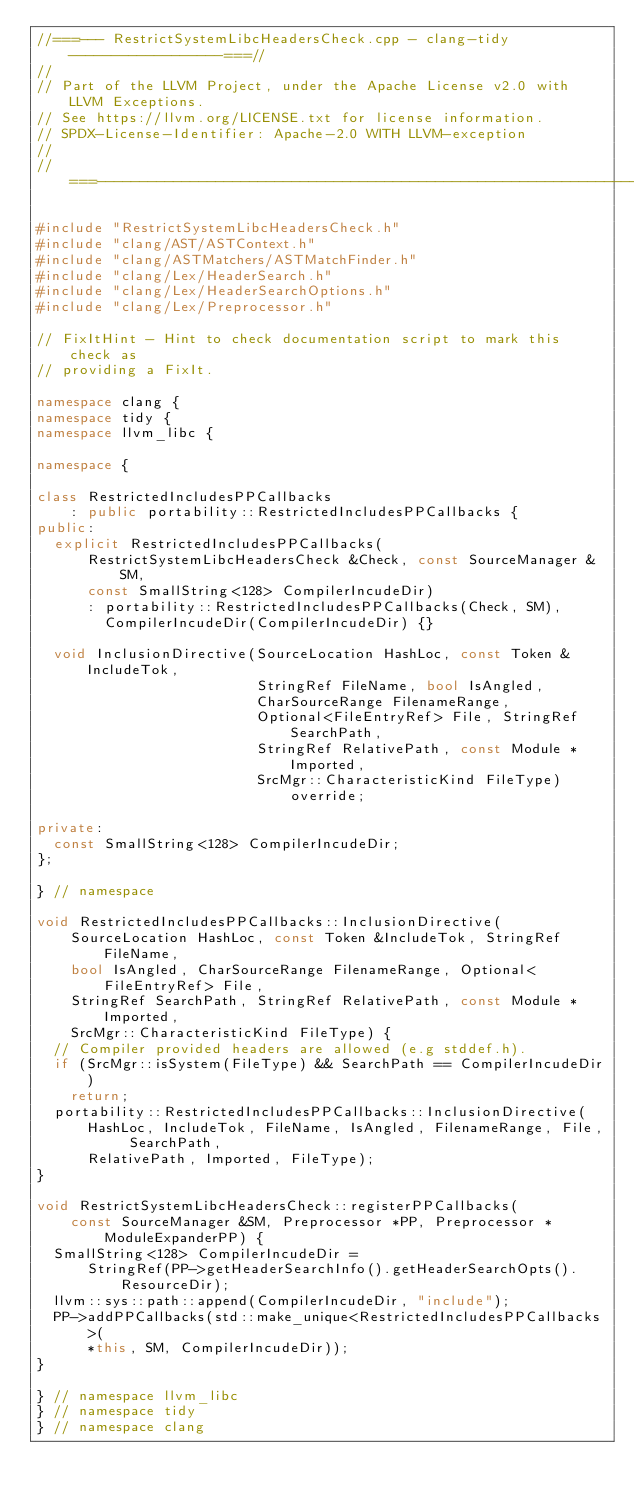<code> <loc_0><loc_0><loc_500><loc_500><_C++_>//===--- RestrictSystemLibcHeadersCheck.cpp - clang-tidy ------------------===//
//
// Part of the LLVM Project, under the Apache License v2.0 with LLVM Exceptions.
// See https://llvm.org/LICENSE.txt for license information.
// SPDX-License-Identifier: Apache-2.0 WITH LLVM-exception
//
//===----------------------------------------------------------------------===//

#include "RestrictSystemLibcHeadersCheck.h"
#include "clang/AST/ASTContext.h"
#include "clang/ASTMatchers/ASTMatchFinder.h"
#include "clang/Lex/HeaderSearch.h"
#include "clang/Lex/HeaderSearchOptions.h"
#include "clang/Lex/Preprocessor.h"

// FixItHint - Hint to check documentation script to mark this check as
// providing a FixIt.

namespace clang {
namespace tidy {
namespace llvm_libc {

namespace {

class RestrictedIncludesPPCallbacks
    : public portability::RestrictedIncludesPPCallbacks {
public:
  explicit RestrictedIncludesPPCallbacks(
      RestrictSystemLibcHeadersCheck &Check, const SourceManager &SM,
      const SmallString<128> CompilerIncudeDir)
      : portability::RestrictedIncludesPPCallbacks(Check, SM),
        CompilerIncudeDir(CompilerIncudeDir) {}

  void InclusionDirective(SourceLocation HashLoc, const Token &IncludeTok,
                          StringRef FileName, bool IsAngled,
                          CharSourceRange FilenameRange,
                          Optional<FileEntryRef> File, StringRef SearchPath,
                          StringRef RelativePath, const Module *Imported,
                          SrcMgr::CharacteristicKind FileType) override;

private:
  const SmallString<128> CompilerIncudeDir;
};

} // namespace

void RestrictedIncludesPPCallbacks::InclusionDirective(
    SourceLocation HashLoc, const Token &IncludeTok, StringRef FileName,
    bool IsAngled, CharSourceRange FilenameRange, Optional<FileEntryRef> File,
    StringRef SearchPath, StringRef RelativePath, const Module *Imported,
    SrcMgr::CharacteristicKind FileType) {
  // Compiler provided headers are allowed (e.g stddef.h).
  if (SrcMgr::isSystem(FileType) && SearchPath == CompilerIncudeDir)
    return;
  portability::RestrictedIncludesPPCallbacks::InclusionDirective(
      HashLoc, IncludeTok, FileName, IsAngled, FilenameRange, File, SearchPath,
      RelativePath, Imported, FileType);
}

void RestrictSystemLibcHeadersCheck::registerPPCallbacks(
    const SourceManager &SM, Preprocessor *PP, Preprocessor *ModuleExpanderPP) {
  SmallString<128> CompilerIncudeDir =
      StringRef(PP->getHeaderSearchInfo().getHeaderSearchOpts().ResourceDir);
  llvm::sys::path::append(CompilerIncudeDir, "include");
  PP->addPPCallbacks(std::make_unique<RestrictedIncludesPPCallbacks>(
      *this, SM, CompilerIncudeDir));
}

} // namespace llvm_libc
} // namespace tidy
} // namespace clang
</code> 